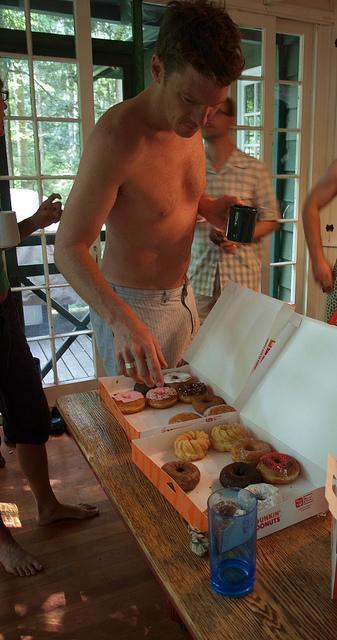What color is the icing on the top of the donuts underneath of the man's hand who is looking to eat?
Indicate the correct response and explain using: 'Answer: answer
Rationale: rationale.'
Options: Pink, black, red, white. Answer: pink.
Rationale: The color is pink. What is the donut called that has ridges down the sides?
Pick the correct solution from the four options below to address the question.
Options: Apple fritter, eclair, long john, cruller. Cruller. 